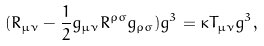Convert formula to latex. <formula><loc_0><loc_0><loc_500><loc_500>( R _ { \mu \nu } - \frac { 1 } { 2 } g _ { \mu \nu } R ^ { \rho \sigma } g _ { \rho \sigma } ) g ^ { 3 } = \kappa T _ { \mu \nu } g ^ { 3 } ,</formula> 